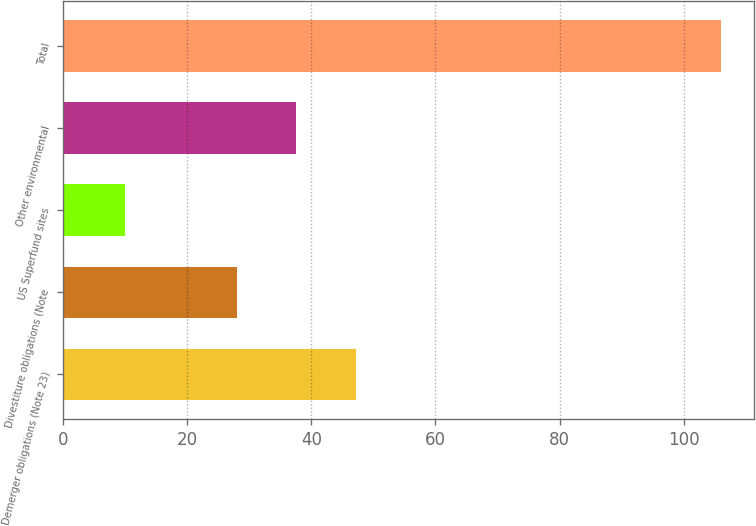Convert chart. <chart><loc_0><loc_0><loc_500><loc_500><bar_chart><fcel>Demerger obligations (Note 23)<fcel>Divestiture obligations (Note<fcel>US Superfund sites<fcel>Other environmental<fcel>Total<nl><fcel>47.2<fcel>28<fcel>10<fcel>37.6<fcel>106<nl></chart> 